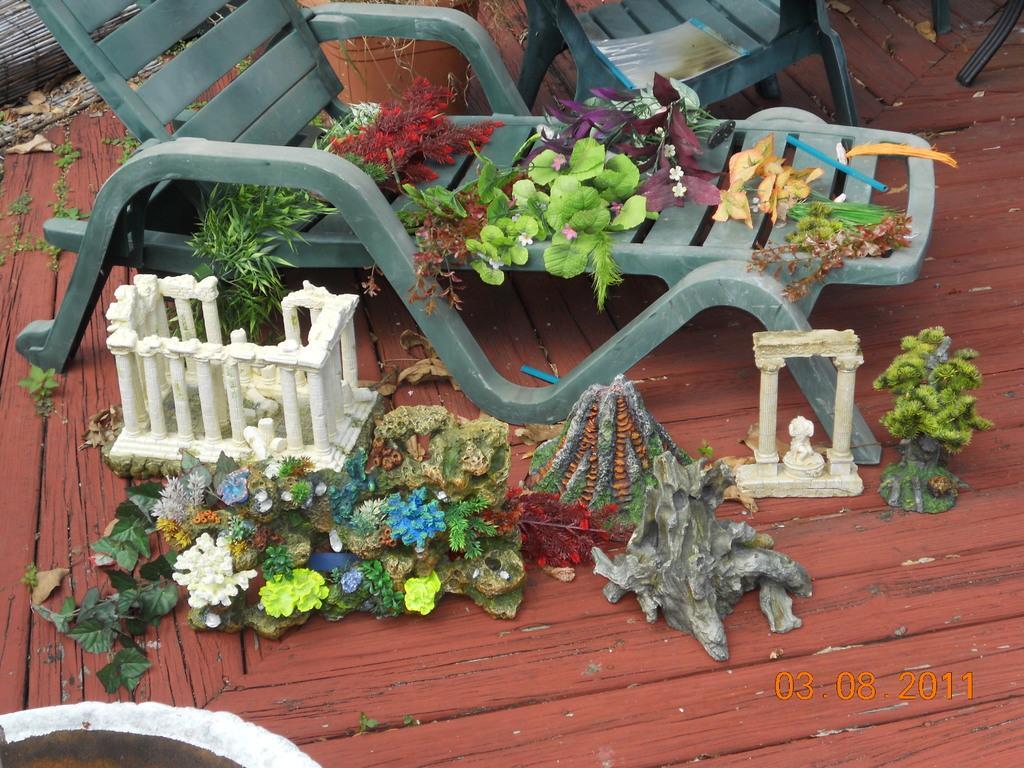Describe this image in one or two sentences. In this image I can see some objects on the chair. I can also see some objects on the wooden floor. 